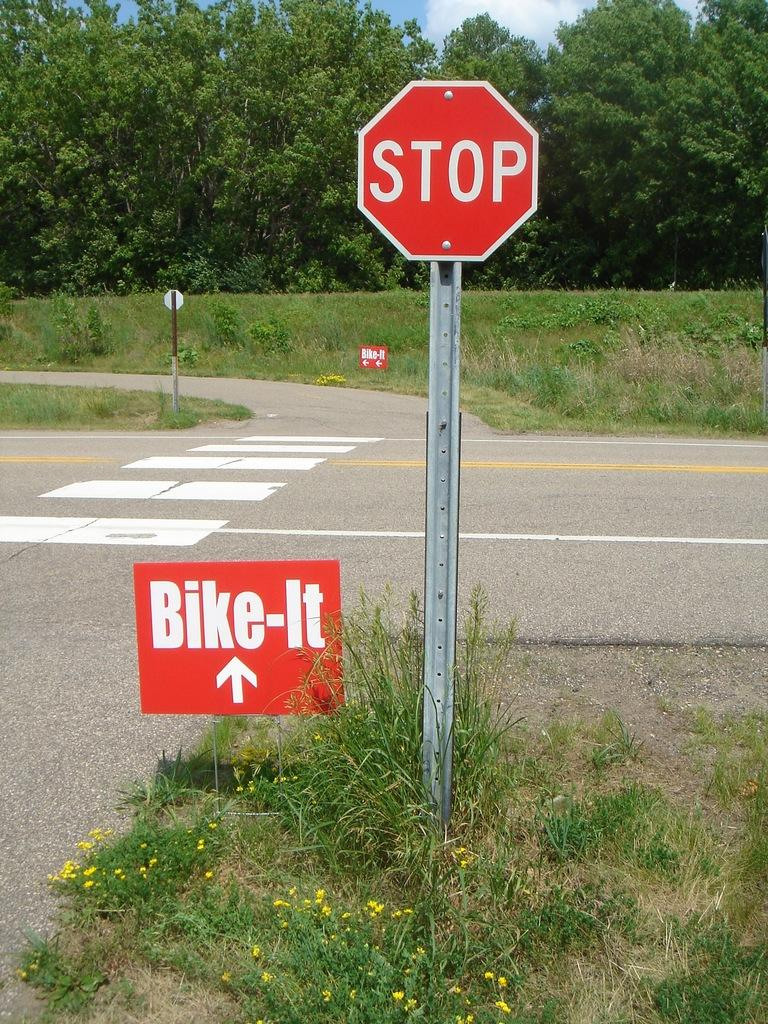<image>
Relay a brief, clear account of the picture shown. Next to a stop sign is a red Bike-It sign. 